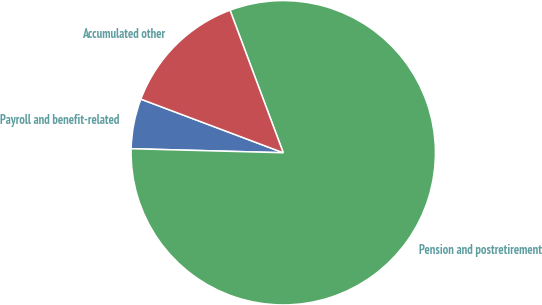<chart> <loc_0><loc_0><loc_500><loc_500><pie_chart><fcel>Payroll and benefit-related<fcel>Pension and postretirement<fcel>Accumulated other<nl><fcel>5.31%<fcel>81.11%<fcel>13.58%<nl></chart> 